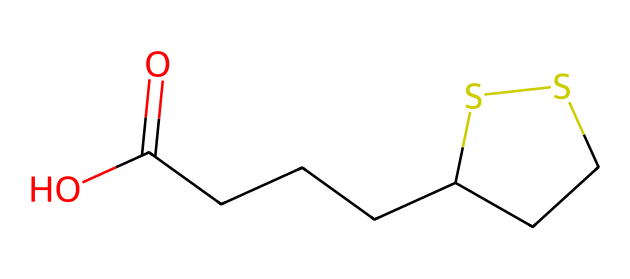what is the molecular formula of lipoic acid? To derive the molecular formula, count the number of each type of atom in the SMILES representation. The SMILES indicates the presence of 8 carbon atoms (C), 14 hydrogen atoms (H), 2 oxygen atoms (O), and 2 sulfur atoms (S). Thus, the molecular formula is C8H14O2S2.
Answer: C8H14O2S2 how many sulfur atoms are present in lipoic acid? By examining the SMILES representation, specifically looking at the 'S' characters, we see that there are two sulfur atoms in the structure.
Answer: 2 what type of bonding is likely present between the carbon atoms in lipoic acid? The SMILES structure shows the carbon atoms are connected in a chain with single bonds and a ring structure. This suggests that the carbon atoms are primarily connected through sigma bonds, typical for carbon-carbon bonding.
Answer: single bonds does lipoic acid contain a carboxylic acid functional group? The presence of the -COOH group in the SMILES indicates a carboxylic acid functional group, confirming that lipoic acid indeed contains this feature.
Answer: yes what role do sulfur atoms play in the structure of lipoic acid? The sulfur atoms are integral to the ring structure formed in lipoic acid, providing specific chemical properties such as redox activity, which may contribute to its neuroprotective effects.
Answer: ring structure 